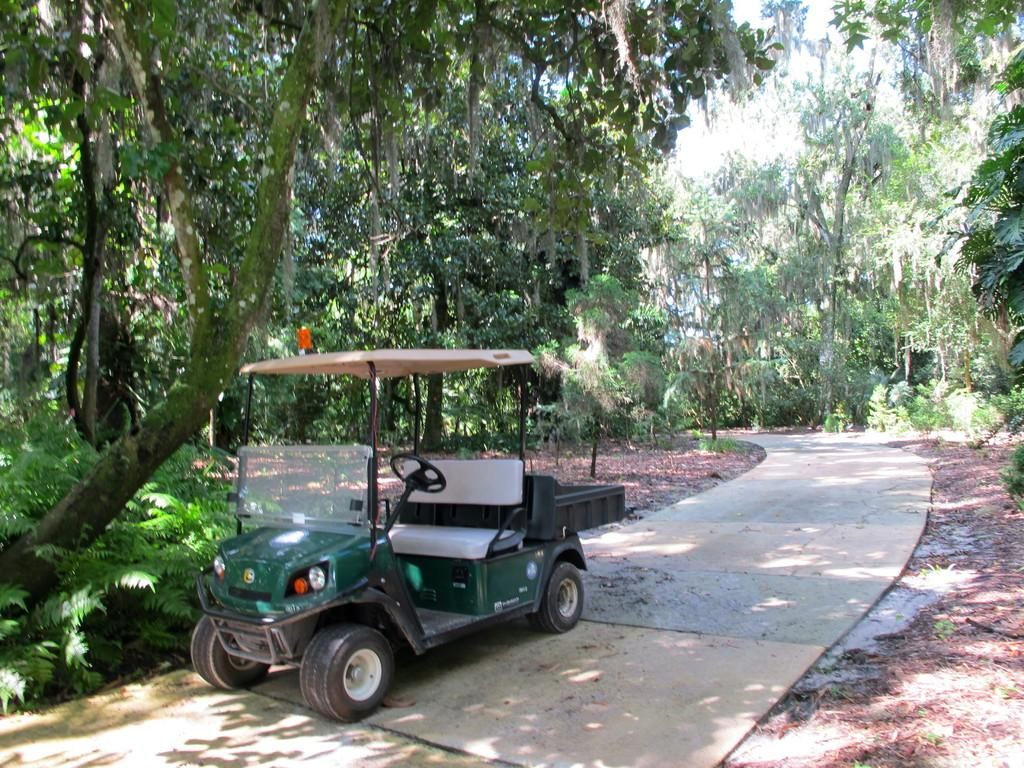What type of motor vehicle can be seen on the road in the image? The image shows a motor vehicle on the road, but the specific type is not mentioned. What is scattered on the ground in the image? Shredded leaves are visible in the image. What type of vegetation is present in the image? There are trees and plants in the image. What part of the natural environment is visible in the image? The sky is visible in the image. What note is being played by the flag in the image? There is no flag or note present in the image. How many cents are visible in the image? There are no cents visible in the image. 